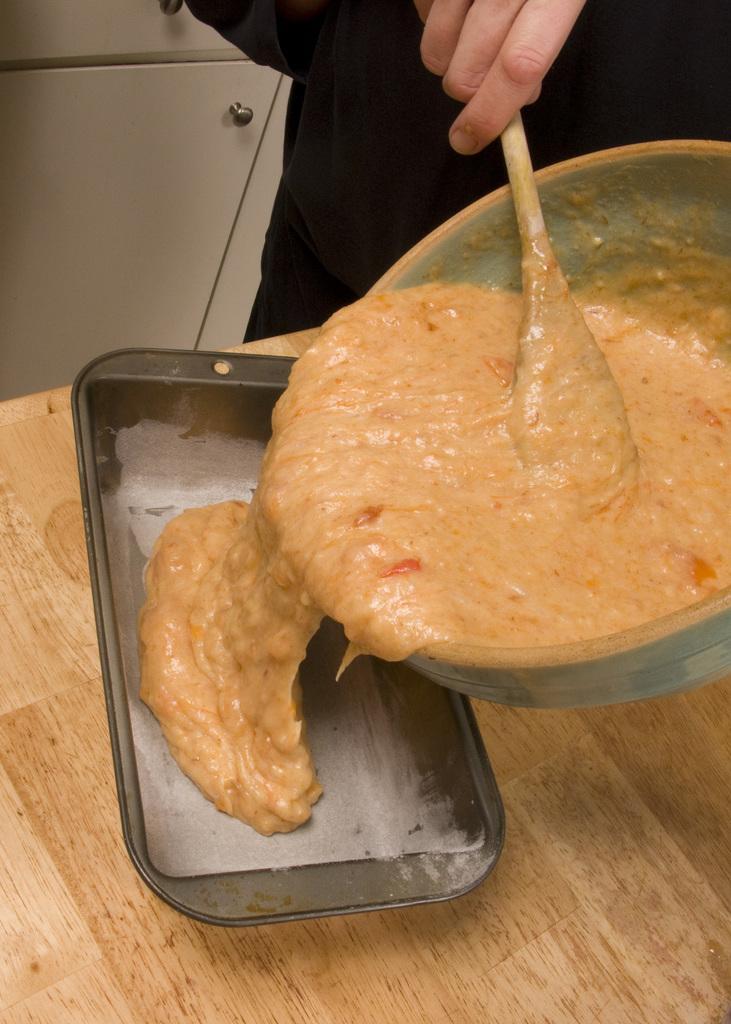How would you summarize this image in a sentence or two? In this image there is a person standing and holding a spoon and pouring the food item in the tray , which is on the table, and in the background there is a cupboard. 